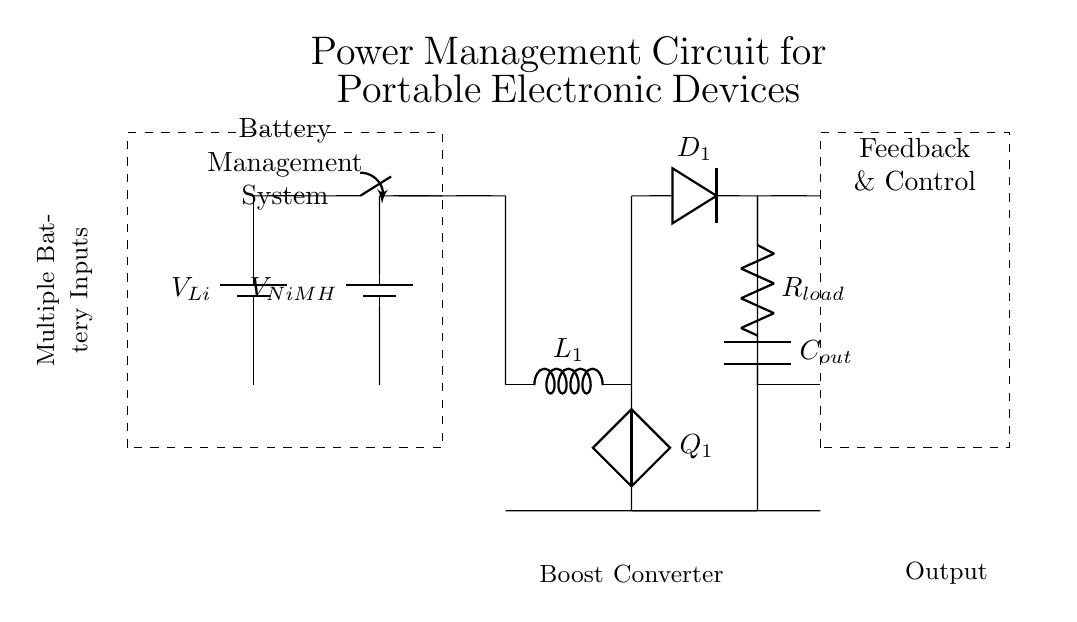What are the types of batteries used? The circuit shows two battery types: Lithium-ion and Nickel-Metal Hydride, labeled as V_Li and V_NiMH.
Answer: Lithium-ion, Nickel-Metal Hydride What is the purpose of the switch in the circuit? The switch allows selection between the two battery inputs, effectively connecting one battery to the rest of the circuit based on the desired voltage source.
Answer: Switch for battery selection What component is used to boost voltage? The circuit includes a boost converter, which increases the voltage from the selected battery to the required output level for the load.
Answer: Boost converter What does the dashed rectangle labeled 'Feedback & Control' represent? This section likely contains the control circuitry that monitors the output voltage and manages the operation of the boost converter to maintain a stable output voltage.
Answer: Feedback and control circuit How many resistive loads are shown in the circuit? There is one resistive load indicated in the circuit diagram, labeled as R_load, connected to the output of the boost converter.
Answer: One resistive load What is the function of the inductor labeled L_1? The inductor L_1 is used in the boost converter to store energy and facilitate the voltage boosting process when the circuit operates.
Answer: Energy storage in boost converter 